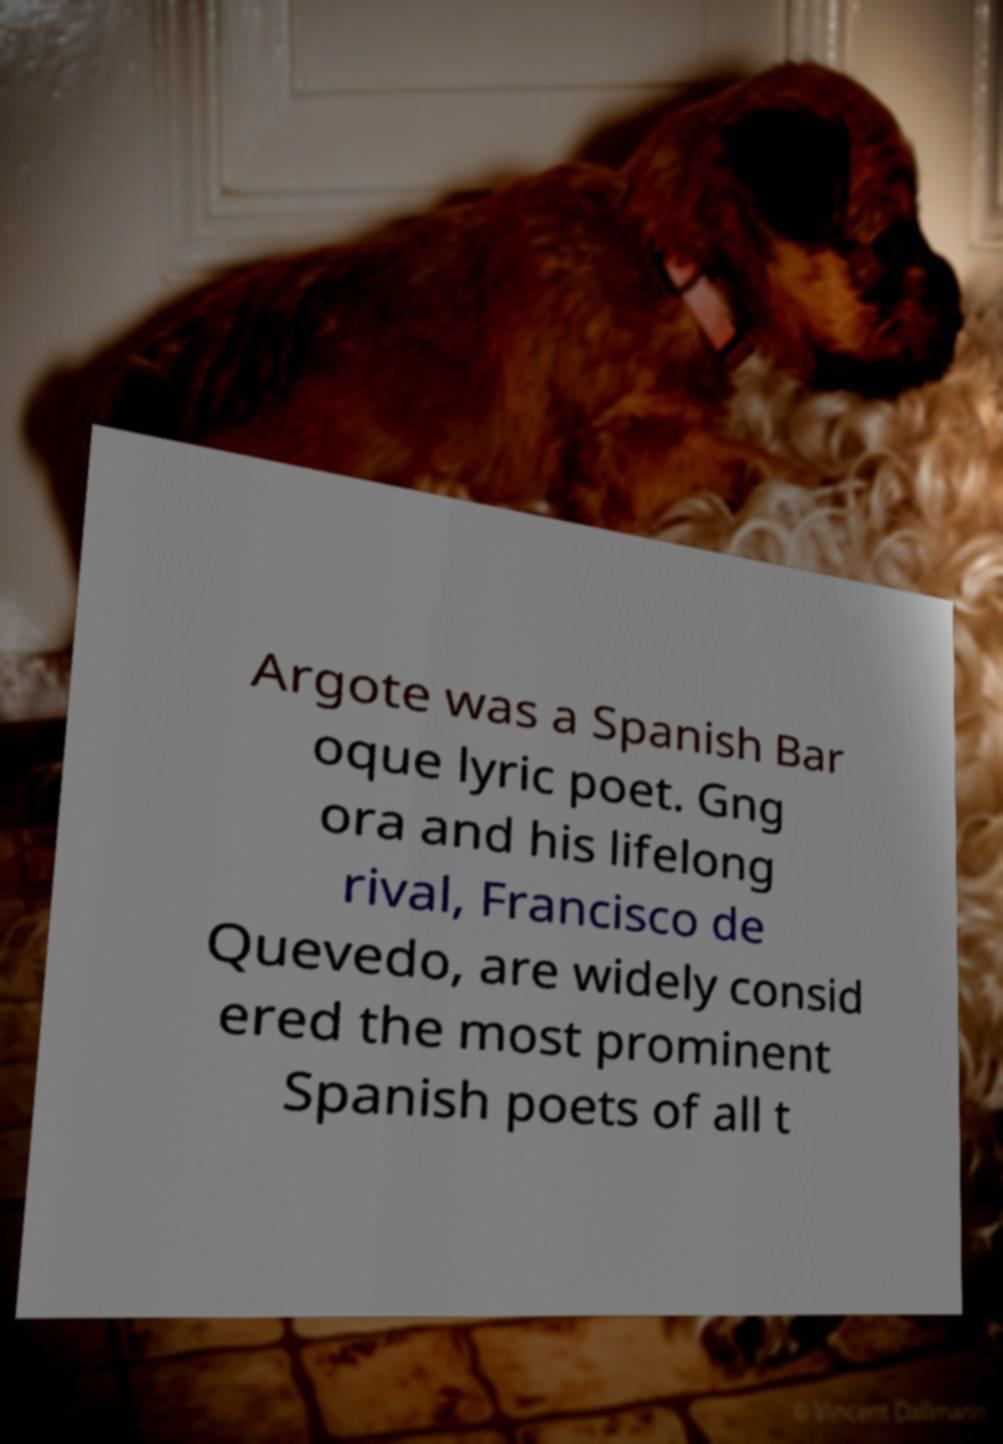I need the written content from this picture converted into text. Can you do that? Argote was a Spanish Bar oque lyric poet. Gng ora and his lifelong rival, Francisco de Quevedo, are widely consid ered the most prominent Spanish poets of all t 